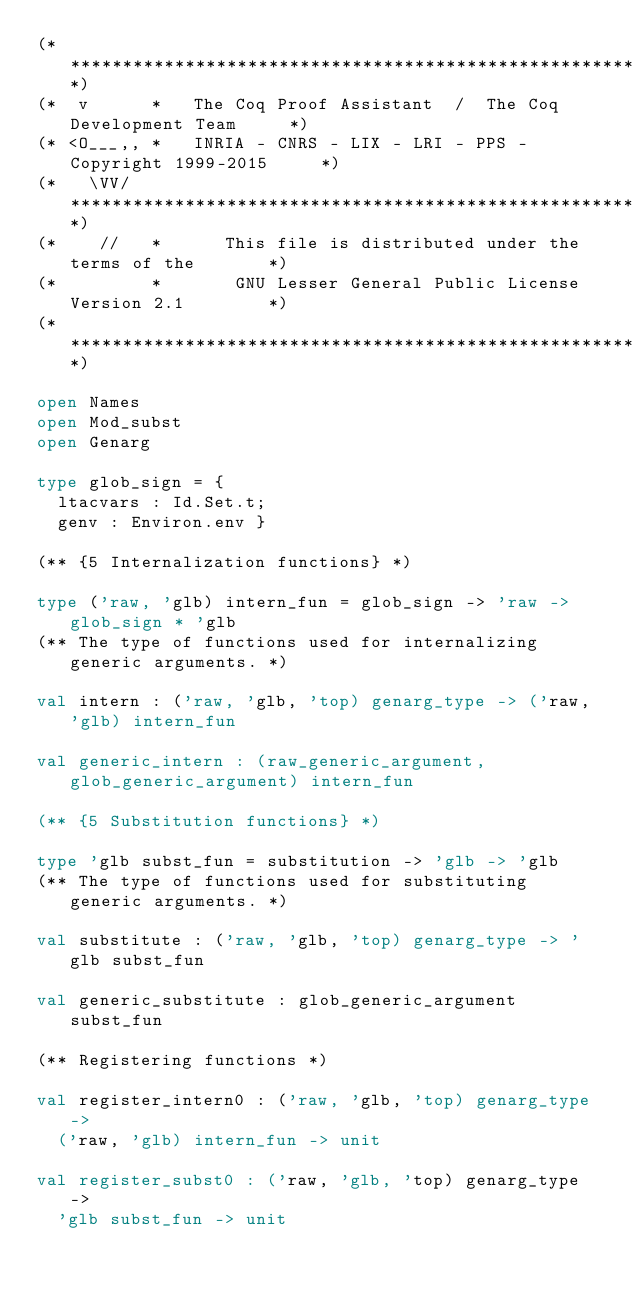<code> <loc_0><loc_0><loc_500><loc_500><_OCaml_>(************************************************************************)
(*  v      *   The Coq Proof Assistant  /  The Coq Development Team     *)
(* <O___,, *   INRIA - CNRS - LIX - LRI - PPS - Copyright 1999-2015     *)
(*   \VV/  **************************************************************)
(*    //   *      This file is distributed under the terms of the       *)
(*         *       GNU Lesser General Public License Version 2.1        *)
(************************************************************************)

open Names
open Mod_subst
open Genarg

type glob_sign = {
  ltacvars : Id.Set.t;
  genv : Environ.env }

(** {5 Internalization functions} *)

type ('raw, 'glb) intern_fun = glob_sign -> 'raw -> glob_sign * 'glb
(** The type of functions used for internalizing generic arguments. *)

val intern : ('raw, 'glb, 'top) genarg_type -> ('raw, 'glb) intern_fun

val generic_intern : (raw_generic_argument, glob_generic_argument) intern_fun

(** {5 Substitution functions} *)

type 'glb subst_fun = substitution -> 'glb -> 'glb
(** The type of functions used for substituting generic arguments. *)

val substitute : ('raw, 'glb, 'top) genarg_type -> 'glb subst_fun

val generic_substitute : glob_generic_argument subst_fun

(** Registering functions *)

val register_intern0 : ('raw, 'glb, 'top) genarg_type ->
  ('raw, 'glb) intern_fun -> unit

val register_subst0 : ('raw, 'glb, 'top) genarg_type ->
  'glb subst_fun -> unit
</code> 